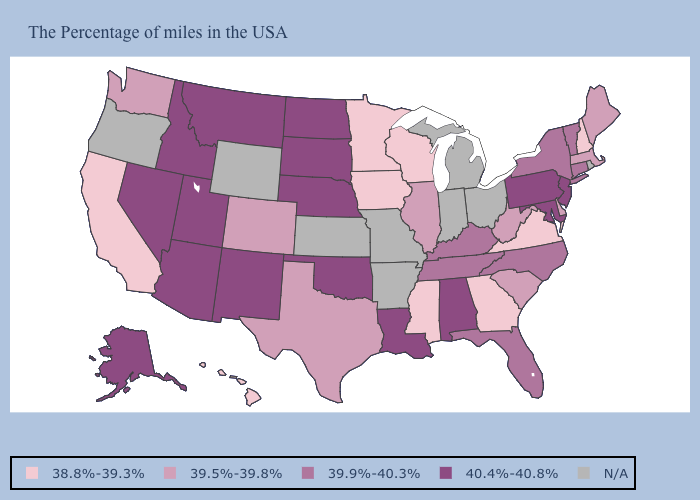Name the states that have a value in the range 38.8%-39.3%?
Be succinct. New Hampshire, Virginia, Georgia, Wisconsin, Mississippi, Minnesota, Iowa, California, Hawaii. What is the value of Virginia?
Quick response, please. 38.8%-39.3%. Name the states that have a value in the range 38.8%-39.3%?
Keep it brief. New Hampshire, Virginia, Georgia, Wisconsin, Mississippi, Minnesota, Iowa, California, Hawaii. Does the first symbol in the legend represent the smallest category?
Answer briefly. Yes. Which states have the lowest value in the USA?
Short answer required. New Hampshire, Virginia, Georgia, Wisconsin, Mississippi, Minnesota, Iowa, California, Hawaii. Does California have the lowest value in the West?
Be succinct. Yes. Name the states that have a value in the range 38.8%-39.3%?
Concise answer only. New Hampshire, Virginia, Georgia, Wisconsin, Mississippi, Minnesota, Iowa, California, Hawaii. What is the highest value in the USA?
Answer briefly. 40.4%-40.8%. Which states have the highest value in the USA?
Short answer required. New Jersey, Maryland, Pennsylvania, Alabama, Louisiana, Nebraska, Oklahoma, South Dakota, North Dakota, New Mexico, Utah, Montana, Arizona, Idaho, Nevada, Alaska. How many symbols are there in the legend?
Answer briefly. 5. Among the states that border Pennsylvania , which have the highest value?
Answer briefly. New Jersey, Maryland. Name the states that have a value in the range 40.4%-40.8%?
Answer briefly. New Jersey, Maryland, Pennsylvania, Alabama, Louisiana, Nebraska, Oklahoma, South Dakota, North Dakota, New Mexico, Utah, Montana, Arizona, Idaho, Nevada, Alaska. What is the value of Nevada?
Be succinct. 40.4%-40.8%. Which states have the lowest value in the Northeast?
Be succinct. New Hampshire. What is the value of Wisconsin?
Be succinct. 38.8%-39.3%. 